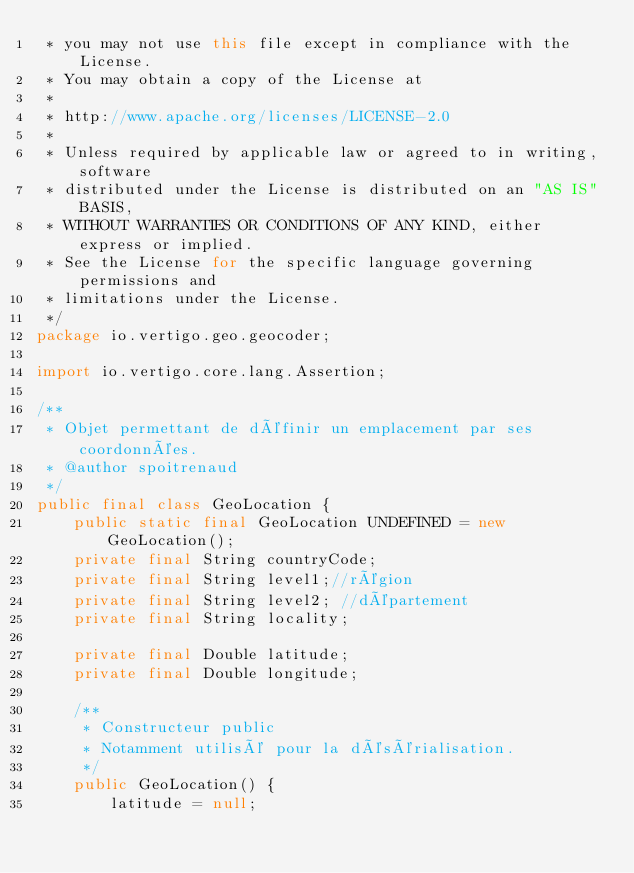Convert code to text. <code><loc_0><loc_0><loc_500><loc_500><_Java_> * you may not use this file except in compliance with the License.
 * You may obtain a copy of the License at
 *
 * http://www.apache.org/licenses/LICENSE-2.0
 *
 * Unless required by applicable law or agreed to in writing, software
 * distributed under the License is distributed on an "AS IS" BASIS,
 * WITHOUT WARRANTIES OR CONDITIONS OF ANY KIND, either express or implied.
 * See the License for the specific language governing permissions and
 * limitations under the License.
 */
package io.vertigo.geo.geocoder;

import io.vertigo.core.lang.Assertion;

/**
 * Objet permettant de définir un emplacement par ses coordonnées.
 * @author spoitrenaud
 */
public final class GeoLocation {
	public static final GeoLocation UNDEFINED = new GeoLocation();
	private final String countryCode;
	private final String level1;//région
	private final String level2; //département
	private final String locality;

	private final Double latitude;
	private final Double longitude;

	/**
	 * Constructeur public
	 * Notamment utilisé pour la désérialisation.
	 */
	public GeoLocation() {
		latitude = null;</code> 